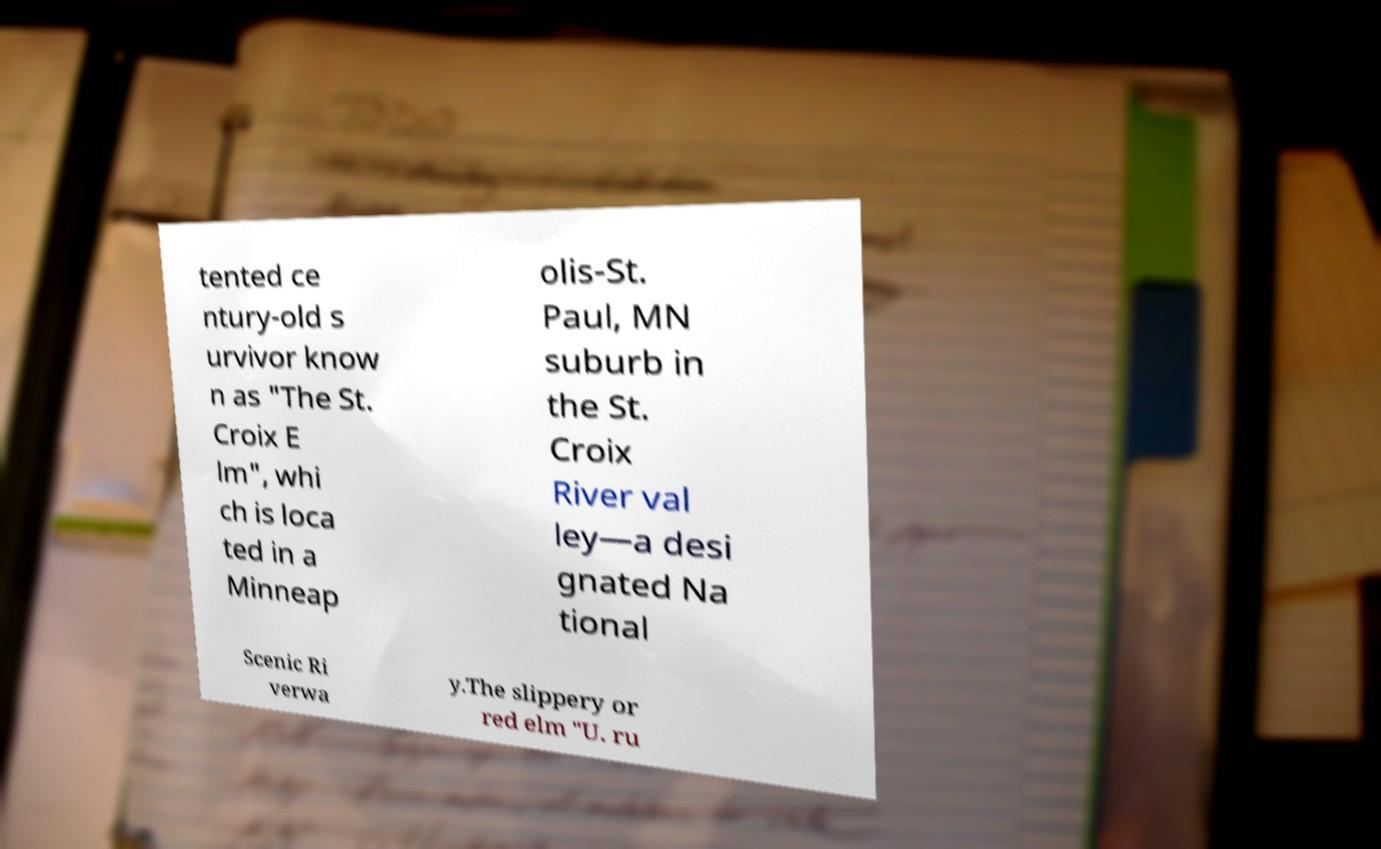Could you extract and type out the text from this image? tented ce ntury-old s urvivor know n as "The St. Croix E lm", whi ch is loca ted in a Minneap olis-St. Paul, MN suburb in the St. Croix River val ley—a desi gnated Na tional Scenic Ri verwa y.The slippery or red elm "U. ru 